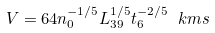Convert formula to latex. <formula><loc_0><loc_0><loc_500><loc_500>V = 6 4 n _ { 0 } ^ { - 1 / 5 } L _ { 3 9 } ^ { 1 / 5 } t _ { 6 } ^ { - 2 / 5 } \ k m s</formula> 